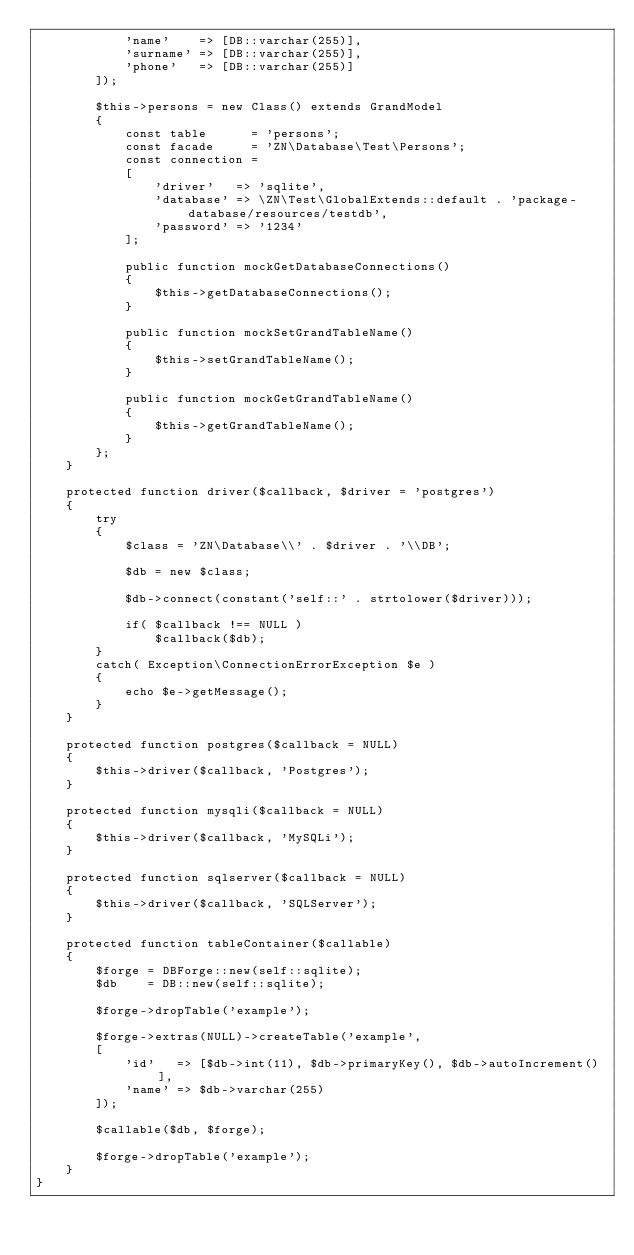Convert code to text. <code><loc_0><loc_0><loc_500><loc_500><_PHP_>            'name'    => [DB::varchar(255)],
            'surname' => [DB::varchar(255)],
            'phone'   => [DB::varchar(255)]
        ]);

        $this->persons = new Class() extends GrandModel
        {
            const table      = 'persons';
            const facade     = 'ZN\Database\Test\Persons';
            const connection = 
            [
                'driver'   => 'sqlite',
                'database' => \ZN\Test\GlobalExtends::default . 'package-database/resources/testdb',
                'password' => '1234'
            ];

            public function mockGetDatabaseConnections()
            {
                $this->getDatabaseConnections();
            }

            public function mockSetGrandTableName()
            {
                $this->setGrandTableName();
            }

            public function mockGetGrandTableName()
            {
                $this->getGrandTableName();
            }
        };
    }

    protected function driver($callback, $driver = 'postgres')
    {
        try
        {
            $class = 'ZN\Database\\' . $driver . '\\DB';

            $db = new $class;

            $db->connect(constant('self::' . strtolower($driver)));

            if( $callback !== NULL )
                $callback($db);
        }
        catch( Exception\ConnectionErrorException $e )
        {
            echo $e->getMessage();
        }
    }

    protected function postgres($callback = NULL)
    {
        $this->driver($callback, 'Postgres');
    }

    protected function mysqli($callback = NULL)
    {
        $this->driver($callback, 'MySQLi');
    }

    protected function sqlserver($callback = NULL)
    {
        $this->driver($callback, 'SQLServer');
    }

    protected function tableContainer($callable)
    {
        $forge = DBForge::new(self::sqlite);
        $db    = DB::new(self::sqlite);

        $forge->dropTable('example');

        $forge->extras(NULL)->createTable('example', 
        [
            'id'   => [$db->int(11), $db->primaryKey(), $db->autoIncrement()],
            'name' => $db->varchar(255)
        ]);

        $callable($db, $forge);
        
        $forge->dropTable('example');
    }
}</code> 